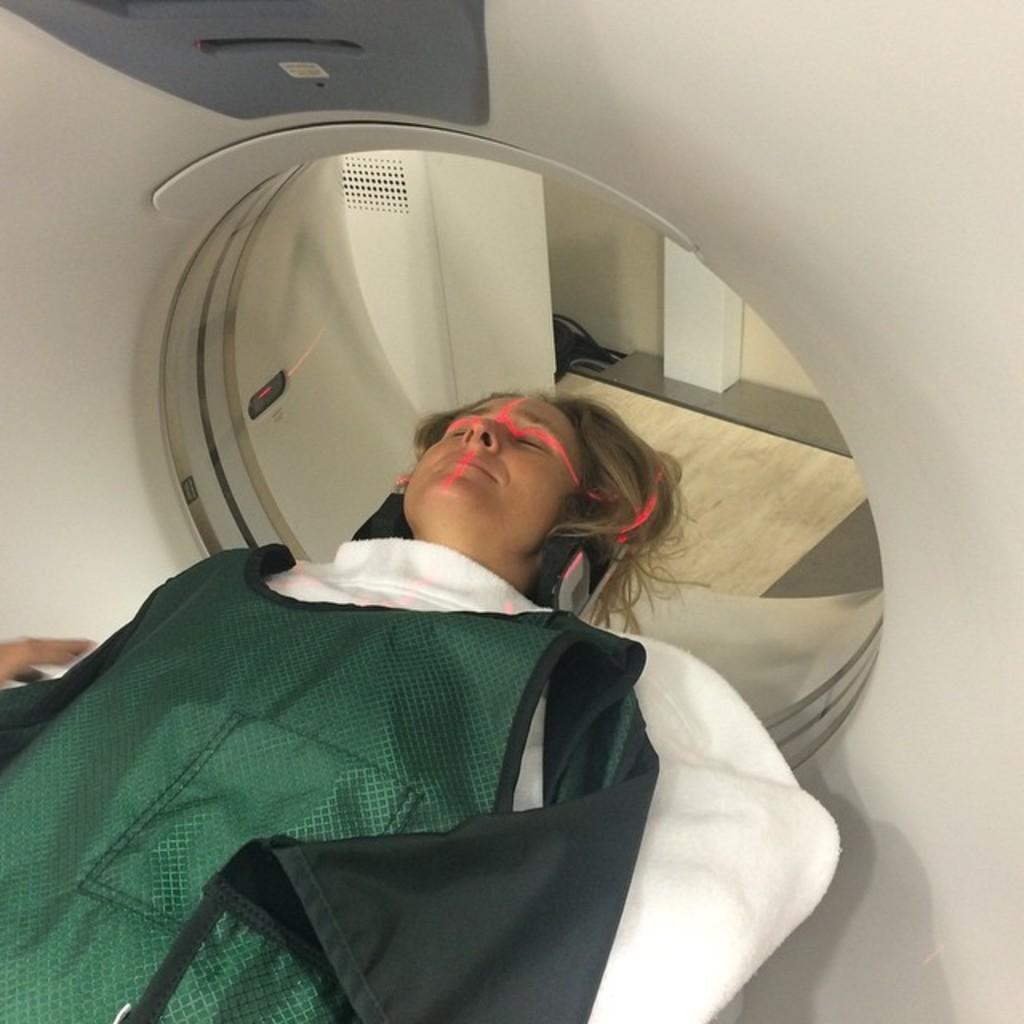How would you summarize this image in a sentence or two? In the image we can see there is a woman lying on the bed and there is a full body CT scan machine. 